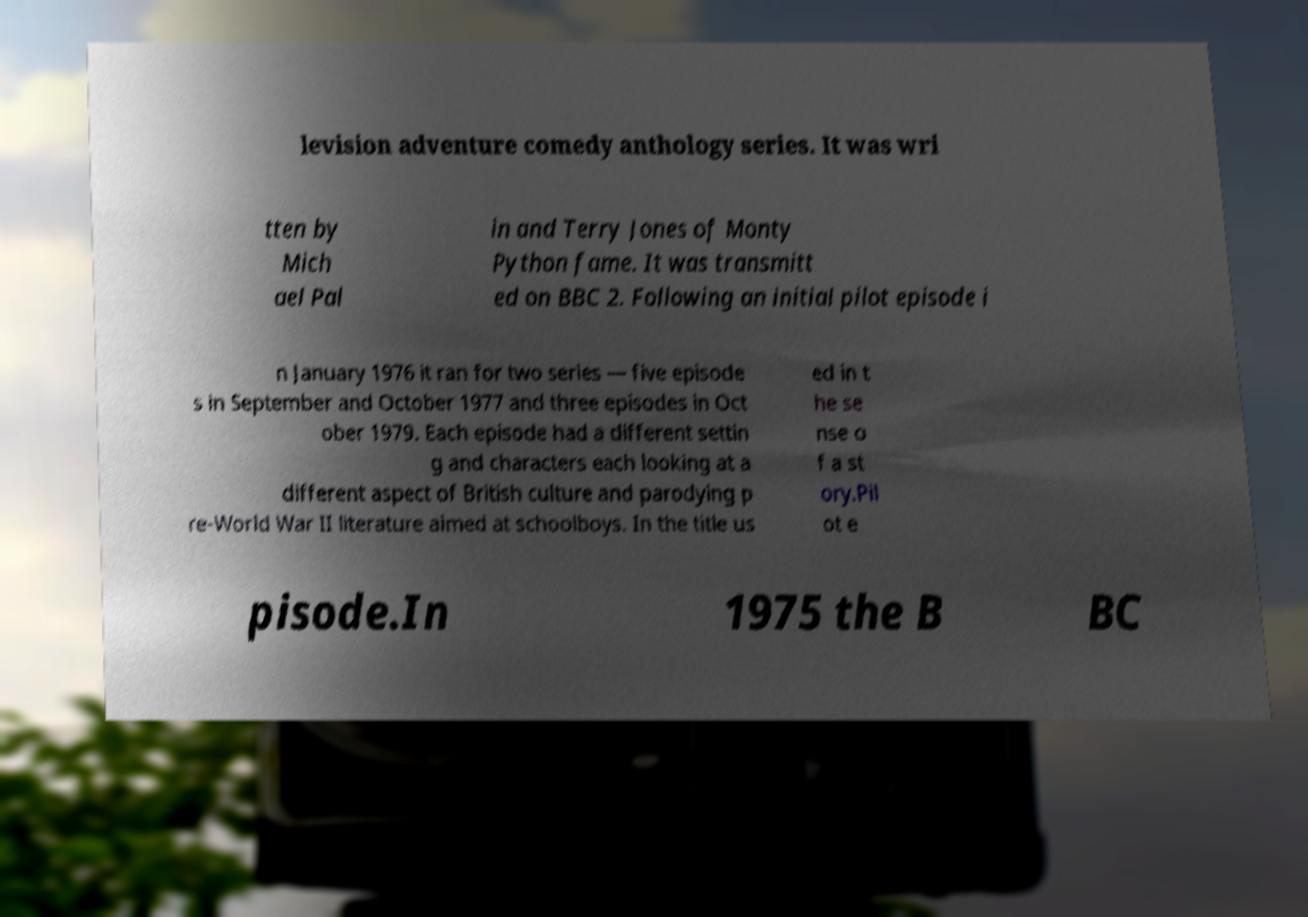I need the written content from this picture converted into text. Can you do that? levision adventure comedy anthology series. It was wri tten by Mich ael Pal in and Terry Jones of Monty Python fame. It was transmitt ed on BBC 2. Following an initial pilot episode i n January 1976 it ran for two series — five episode s in September and October 1977 and three episodes in Oct ober 1979. Each episode had a different settin g and characters each looking at a different aspect of British culture and parodying p re-World War II literature aimed at schoolboys. In the title us ed in t he se nse o f a st ory.Pil ot e pisode.In 1975 the B BC 